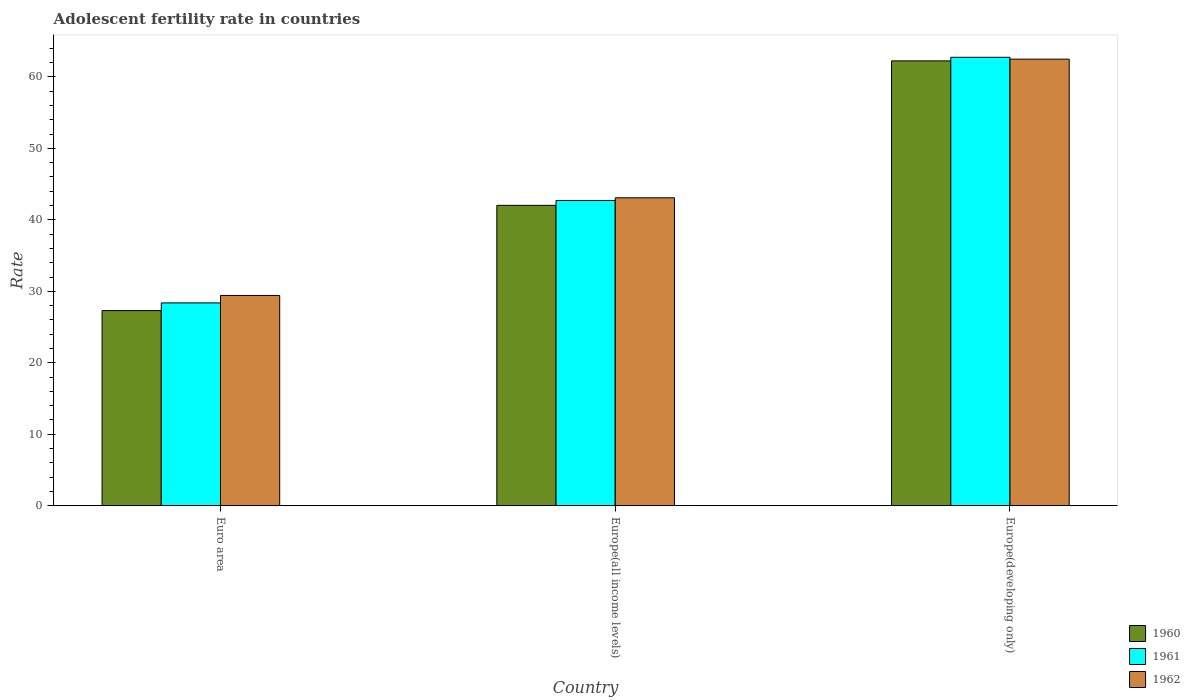How many different coloured bars are there?
Offer a terse response. 3. How many groups of bars are there?
Ensure brevity in your answer.  3. How many bars are there on the 3rd tick from the left?
Keep it short and to the point. 3. How many bars are there on the 3rd tick from the right?
Give a very brief answer. 3. What is the label of the 3rd group of bars from the left?
Your answer should be very brief. Europe(developing only). What is the adolescent fertility rate in 1961 in Euro area?
Ensure brevity in your answer.  28.38. Across all countries, what is the maximum adolescent fertility rate in 1960?
Your answer should be compact. 62.24. Across all countries, what is the minimum adolescent fertility rate in 1960?
Keep it short and to the point. 27.3. In which country was the adolescent fertility rate in 1960 maximum?
Offer a terse response. Europe(developing only). What is the total adolescent fertility rate in 1960 in the graph?
Offer a terse response. 131.58. What is the difference between the adolescent fertility rate in 1960 in Euro area and that in Europe(all income levels)?
Offer a terse response. -14.73. What is the difference between the adolescent fertility rate in 1961 in Europe(developing only) and the adolescent fertility rate in 1962 in Europe(all income levels)?
Keep it short and to the point. 19.66. What is the average adolescent fertility rate in 1962 per country?
Ensure brevity in your answer.  45. What is the difference between the adolescent fertility rate of/in 1962 and adolescent fertility rate of/in 1960 in Europe(developing only)?
Your answer should be compact. 0.24. In how many countries, is the adolescent fertility rate in 1961 greater than 12?
Your answer should be compact. 3. What is the ratio of the adolescent fertility rate in 1960 in Euro area to that in Europe(all income levels)?
Your answer should be very brief. 0.65. Is the difference between the adolescent fertility rate in 1962 in Europe(all income levels) and Europe(developing only) greater than the difference between the adolescent fertility rate in 1960 in Europe(all income levels) and Europe(developing only)?
Your answer should be compact. Yes. What is the difference between the highest and the second highest adolescent fertility rate in 1961?
Keep it short and to the point. 14.34. What is the difference between the highest and the lowest adolescent fertility rate in 1962?
Your answer should be very brief. 33.07. What does the 3rd bar from the left in Europe(developing only) represents?
Your response must be concise. 1962. What does the 1st bar from the right in Euro area represents?
Your response must be concise. 1962. Are all the bars in the graph horizontal?
Give a very brief answer. No. What is the difference between two consecutive major ticks on the Y-axis?
Offer a very short reply. 10. Does the graph contain any zero values?
Your answer should be very brief. No. Does the graph contain grids?
Provide a short and direct response. No. Where does the legend appear in the graph?
Offer a terse response. Bottom right. What is the title of the graph?
Keep it short and to the point. Adolescent fertility rate in countries. What is the label or title of the Y-axis?
Provide a short and direct response. Rate. What is the Rate in 1960 in Euro area?
Ensure brevity in your answer.  27.3. What is the Rate in 1961 in Euro area?
Offer a terse response. 28.38. What is the Rate of 1962 in Euro area?
Your answer should be very brief. 29.42. What is the Rate of 1960 in Europe(all income levels)?
Provide a succinct answer. 42.03. What is the Rate in 1961 in Europe(all income levels)?
Your response must be concise. 42.72. What is the Rate of 1962 in Europe(all income levels)?
Keep it short and to the point. 43.09. What is the Rate in 1960 in Europe(developing only)?
Provide a short and direct response. 62.24. What is the Rate in 1961 in Europe(developing only)?
Ensure brevity in your answer.  62.75. What is the Rate of 1962 in Europe(developing only)?
Your answer should be compact. 62.49. Across all countries, what is the maximum Rate of 1960?
Provide a short and direct response. 62.24. Across all countries, what is the maximum Rate in 1961?
Your response must be concise. 62.75. Across all countries, what is the maximum Rate of 1962?
Provide a short and direct response. 62.49. Across all countries, what is the minimum Rate in 1960?
Offer a very short reply. 27.3. Across all countries, what is the minimum Rate in 1961?
Provide a short and direct response. 28.38. Across all countries, what is the minimum Rate of 1962?
Make the answer very short. 29.42. What is the total Rate in 1960 in the graph?
Provide a short and direct response. 131.58. What is the total Rate in 1961 in the graph?
Your answer should be very brief. 133.84. What is the total Rate in 1962 in the graph?
Ensure brevity in your answer.  135. What is the difference between the Rate of 1960 in Euro area and that in Europe(all income levels)?
Your answer should be very brief. -14.73. What is the difference between the Rate in 1961 in Euro area and that in Europe(all income levels)?
Offer a very short reply. -14.34. What is the difference between the Rate in 1962 in Euro area and that in Europe(all income levels)?
Provide a short and direct response. -13.67. What is the difference between the Rate in 1960 in Euro area and that in Europe(developing only)?
Offer a terse response. -34.94. What is the difference between the Rate in 1961 in Euro area and that in Europe(developing only)?
Keep it short and to the point. -34.37. What is the difference between the Rate in 1962 in Euro area and that in Europe(developing only)?
Provide a short and direct response. -33.07. What is the difference between the Rate in 1960 in Europe(all income levels) and that in Europe(developing only)?
Your response must be concise. -20.21. What is the difference between the Rate in 1961 in Europe(all income levels) and that in Europe(developing only)?
Offer a terse response. -20.03. What is the difference between the Rate of 1962 in Europe(all income levels) and that in Europe(developing only)?
Provide a succinct answer. -19.4. What is the difference between the Rate of 1960 in Euro area and the Rate of 1961 in Europe(all income levels)?
Offer a very short reply. -15.41. What is the difference between the Rate of 1960 in Euro area and the Rate of 1962 in Europe(all income levels)?
Your answer should be compact. -15.79. What is the difference between the Rate in 1961 in Euro area and the Rate in 1962 in Europe(all income levels)?
Your response must be concise. -14.71. What is the difference between the Rate in 1960 in Euro area and the Rate in 1961 in Europe(developing only)?
Make the answer very short. -35.44. What is the difference between the Rate of 1960 in Euro area and the Rate of 1962 in Europe(developing only)?
Give a very brief answer. -35.19. What is the difference between the Rate in 1961 in Euro area and the Rate in 1962 in Europe(developing only)?
Provide a succinct answer. -34.11. What is the difference between the Rate of 1960 in Europe(all income levels) and the Rate of 1961 in Europe(developing only)?
Ensure brevity in your answer.  -20.72. What is the difference between the Rate in 1960 in Europe(all income levels) and the Rate in 1962 in Europe(developing only)?
Make the answer very short. -20.46. What is the difference between the Rate in 1961 in Europe(all income levels) and the Rate in 1962 in Europe(developing only)?
Provide a succinct answer. -19.77. What is the average Rate of 1960 per country?
Offer a terse response. 43.86. What is the average Rate of 1961 per country?
Provide a succinct answer. 44.61. What is the average Rate of 1962 per country?
Keep it short and to the point. 45. What is the difference between the Rate in 1960 and Rate in 1961 in Euro area?
Make the answer very short. -1.08. What is the difference between the Rate of 1960 and Rate of 1962 in Euro area?
Your answer should be very brief. -2.12. What is the difference between the Rate in 1961 and Rate in 1962 in Euro area?
Provide a succinct answer. -1.04. What is the difference between the Rate of 1960 and Rate of 1961 in Europe(all income levels)?
Offer a very short reply. -0.69. What is the difference between the Rate of 1960 and Rate of 1962 in Europe(all income levels)?
Keep it short and to the point. -1.06. What is the difference between the Rate in 1961 and Rate in 1962 in Europe(all income levels)?
Make the answer very short. -0.37. What is the difference between the Rate of 1960 and Rate of 1961 in Europe(developing only)?
Provide a short and direct response. -0.5. What is the difference between the Rate of 1960 and Rate of 1962 in Europe(developing only)?
Ensure brevity in your answer.  -0.24. What is the difference between the Rate in 1961 and Rate in 1962 in Europe(developing only)?
Your answer should be compact. 0.26. What is the ratio of the Rate in 1960 in Euro area to that in Europe(all income levels)?
Offer a very short reply. 0.65. What is the ratio of the Rate of 1961 in Euro area to that in Europe(all income levels)?
Provide a succinct answer. 0.66. What is the ratio of the Rate in 1962 in Euro area to that in Europe(all income levels)?
Give a very brief answer. 0.68. What is the ratio of the Rate of 1960 in Euro area to that in Europe(developing only)?
Ensure brevity in your answer.  0.44. What is the ratio of the Rate in 1961 in Euro area to that in Europe(developing only)?
Ensure brevity in your answer.  0.45. What is the ratio of the Rate of 1962 in Euro area to that in Europe(developing only)?
Your response must be concise. 0.47. What is the ratio of the Rate in 1960 in Europe(all income levels) to that in Europe(developing only)?
Keep it short and to the point. 0.68. What is the ratio of the Rate of 1961 in Europe(all income levels) to that in Europe(developing only)?
Give a very brief answer. 0.68. What is the ratio of the Rate of 1962 in Europe(all income levels) to that in Europe(developing only)?
Provide a succinct answer. 0.69. What is the difference between the highest and the second highest Rate in 1960?
Ensure brevity in your answer.  20.21. What is the difference between the highest and the second highest Rate in 1961?
Keep it short and to the point. 20.03. What is the difference between the highest and the second highest Rate in 1962?
Your answer should be compact. 19.4. What is the difference between the highest and the lowest Rate in 1960?
Provide a short and direct response. 34.94. What is the difference between the highest and the lowest Rate in 1961?
Your response must be concise. 34.37. What is the difference between the highest and the lowest Rate of 1962?
Provide a short and direct response. 33.07. 